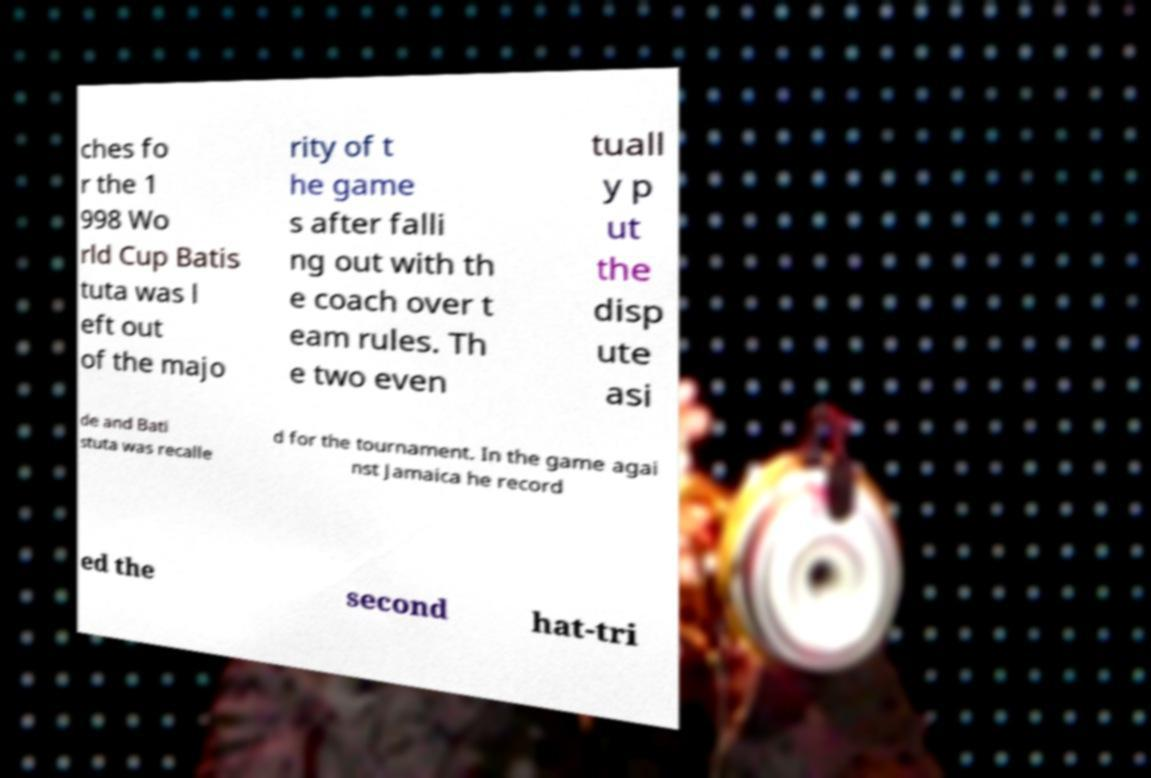There's text embedded in this image that I need extracted. Can you transcribe it verbatim? ches fo r the 1 998 Wo rld Cup Batis tuta was l eft out of the majo rity of t he game s after falli ng out with th e coach over t eam rules. Th e two even tuall y p ut the disp ute asi de and Bati stuta was recalle d for the tournament. In the game agai nst Jamaica he record ed the second hat-tri 